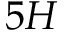Convert formula to latex. <formula><loc_0><loc_0><loc_500><loc_500>5 H</formula> 